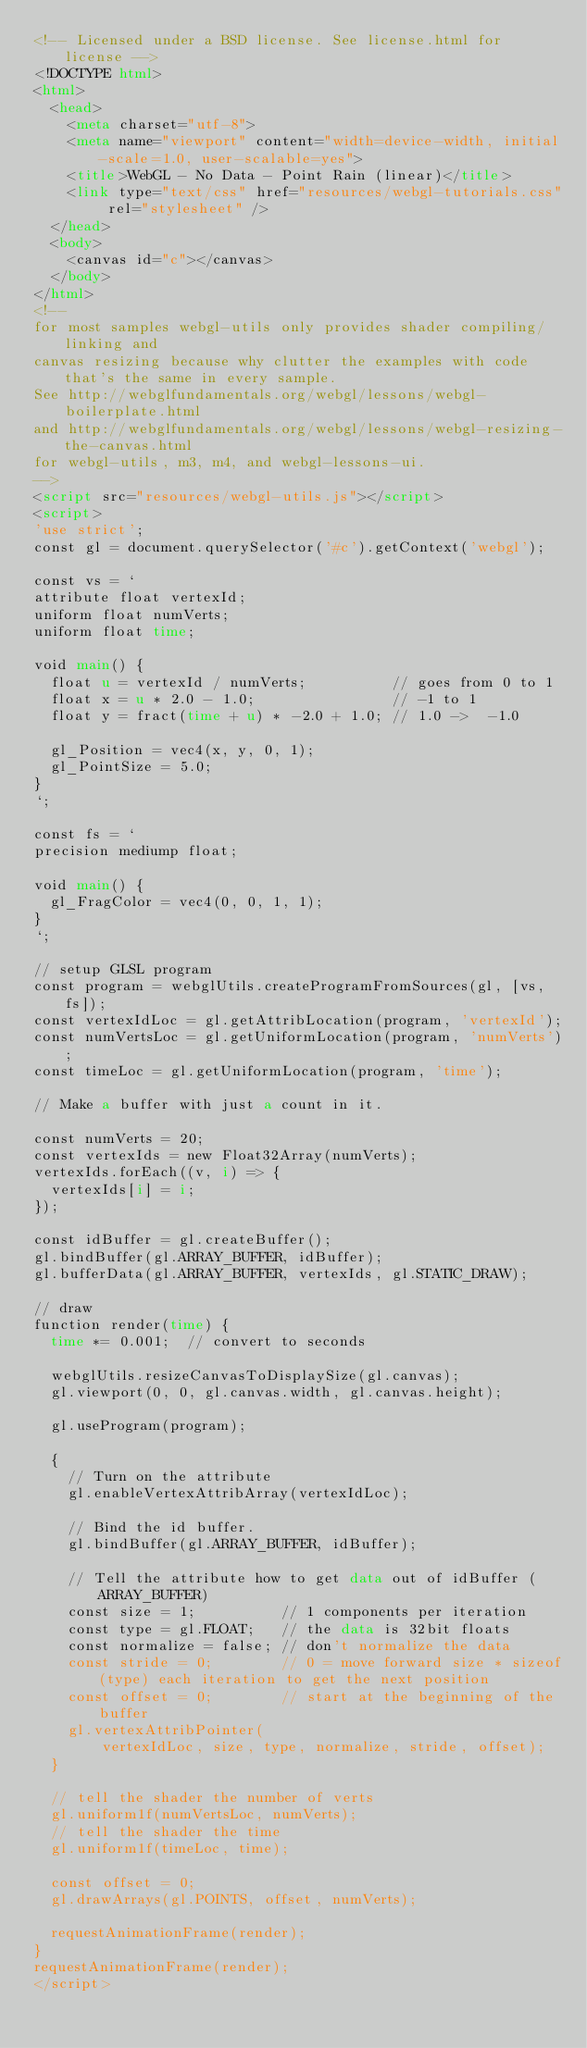Convert code to text. <code><loc_0><loc_0><loc_500><loc_500><_HTML_><!-- Licensed under a BSD license. See license.html for license -->
<!DOCTYPE html>
<html>
  <head>
    <meta charset="utf-8">
    <meta name="viewport" content="width=device-width, initial-scale=1.0, user-scalable=yes">
    <title>WebGL - No Data - Point Rain (linear)</title>
    <link type="text/css" href="resources/webgl-tutorials.css" rel="stylesheet" />
  </head>
  <body>
    <canvas id="c"></canvas>
  </body>
</html>
<!--
for most samples webgl-utils only provides shader compiling/linking and
canvas resizing because why clutter the examples with code that's the same in every sample.
See http://webglfundamentals.org/webgl/lessons/webgl-boilerplate.html
and http://webglfundamentals.org/webgl/lessons/webgl-resizing-the-canvas.html
for webgl-utils, m3, m4, and webgl-lessons-ui.
-->
<script src="resources/webgl-utils.js"></script>
<script>
'use strict';
const gl = document.querySelector('#c').getContext('webgl');

const vs = `
attribute float vertexId;
uniform float numVerts;
uniform float time;

void main() {
  float u = vertexId / numVerts;          // goes from 0 to 1
  float x = u * 2.0 - 1.0;                // -1 to 1
  float y = fract(time + u) * -2.0 + 1.0; // 1.0 ->  -1.0

  gl_Position = vec4(x, y, 0, 1);
  gl_PointSize = 5.0;
}
`;

const fs = `
precision mediump float;

void main() {
  gl_FragColor = vec4(0, 0, 1, 1);
}
`;

// setup GLSL program
const program = webglUtils.createProgramFromSources(gl, [vs, fs]);
const vertexIdLoc = gl.getAttribLocation(program, 'vertexId');
const numVertsLoc = gl.getUniformLocation(program, 'numVerts');
const timeLoc = gl.getUniformLocation(program, 'time');

// Make a buffer with just a count in it.

const numVerts = 20;
const vertexIds = new Float32Array(numVerts);
vertexIds.forEach((v, i) => {
  vertexIds[i] = i;
});

const idBuffer = gl.createBuffer();
gl.bindBuffer(gl.ARRAY_BUFFER, idBuffer);
gl.bufferData(gl.ARRAY_BUFFER, vertexIds, gl.STATIC_DRAW);

// draw
function render(time) {
  time *= 0.001;  // convert to seconds

  webglUtils.resizeCanvasToDisplaySize(gl.canvas);
  gl.viewport(0, 0, gl.canvas.width, gl.canvas.height);

  gl.useProgram(program);

  {
    // Turn on the attribute
    gl.enableVertexAttribArray(vertexIdLoc);

    // Bind the id buffer.
    gl.bindBuffer(gl.ARRAY_BUFFER, idBuffer);

    // Tell the attribute how to get data out of idBuffer (ARRAY_BUFFER)
    const size = 1;          // 1 components per iteration
    const type = gl.FLOAT;   // the data is 32bit floats
    const normalize = false; // don't normalize the data
    const stride = 0;        // 0 = move forward size * sizeof(type) each iteration to get the next position
    const offset = 0;        // start at the beginning of the buffer
    gl.vertexAttribPointer(
        vertexIdLoc, size, type, normalize, stride, offset);
  }

  // tell the shader the number of verts
  gl.uniform1f(numVertsLoc, numVerts);
  // tell the shader the time
  gl.uniform1f(timeLoc, time);

  const offset = 0;
  gl.drawArrays(gl.POINTS, offset, numVerts);

  requestAnimationFrame(render);
}
requestAnimationFrame(render);
</script>

</code> 